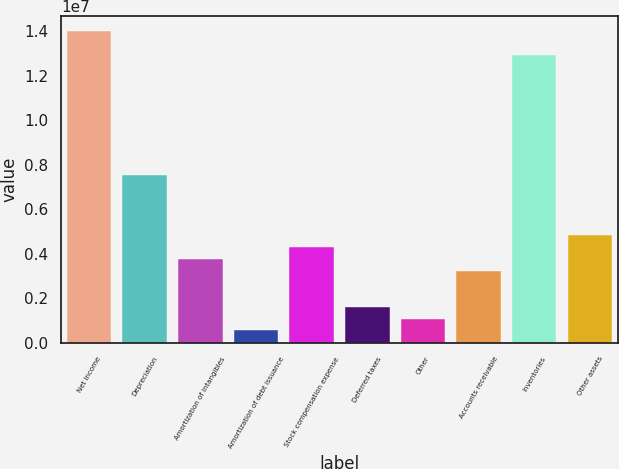Convert chart to OTSL. <chart><loc_0><loc_0><loc_500><loc_500><bar_chart><fcel>Net income<fcel>Depreciation<fcel>Amortization of intangibles<fcel>Amortization of debt issuance<fcel>Stock compensation expense<fcel>Deferred taxes<fcel>Other<fcel>Accounts receivable<fcel>Inventories<fcel>Other assets<nl><fcel>1.39948e+07<fcel>7.53745e+06<fcel>3.77066e+06<fcel>541988<fcel>4.30878e+06<fcel>1.61821e+06<fcel>1.0801e+06<fcel>3.23255e+06<fcel>1.29186e+07<fcel>4.84689e+06<nl></chart> 